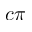Convert formula to latex. <formula><loc_0><loc_0><loc_500><loc_500>c \pi</formula> 